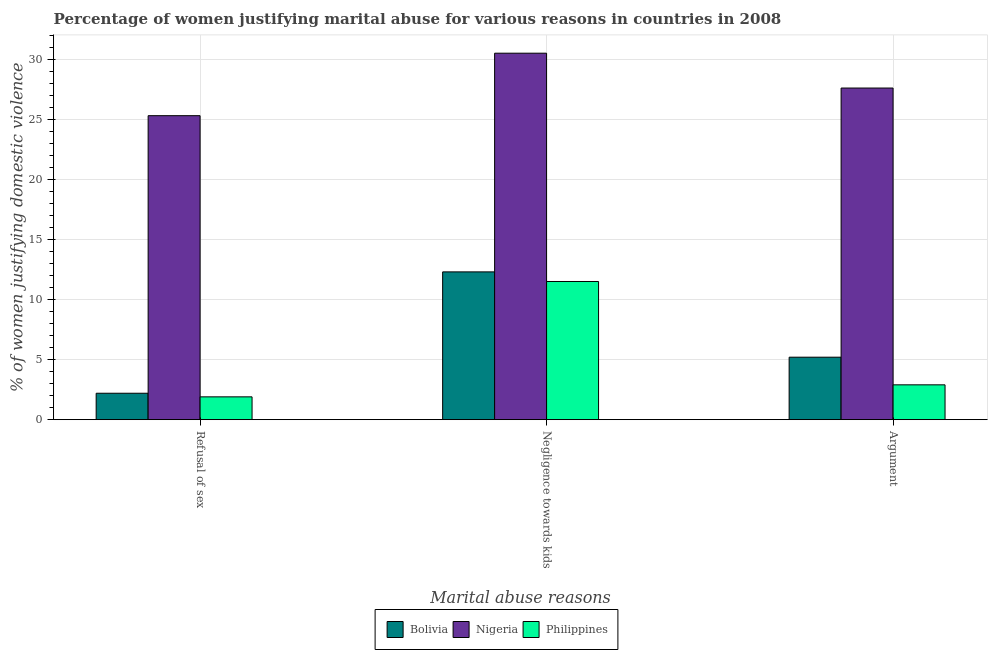How many groups of bars are there?
Offer a very short reply. 3. What is the label of the 2nd group of bars from the left?
Offer a terse response. Negligence towards kids. What is the percentage of women justifying domestic violence due to arguments in Nigeria?
Give a very brief answer. 27.6. Across all countries, what is the maximum percentage of women justifying domestic violence due to arguments?
Provide a succinct answer. 27.6. In which country was the percentage of women justifying domestic violence due to refusal of sex maximum?
Provide a succinct answer. Nigeria. In which country was the percentage of women justifying domestic violence due to negligence towards kids minimum?
Your response must be concise. Philippines. What is the total percentage of women justifying domestic violence due to refusal of sex in the graph?
Your answer should be compact. 29.4. What is the difference between the percentage of women justifying domestic violence due to arguments in Bolivia and that in Philippines?
Offer a terse response. 2.3. What is the difference between the percentage of women justifying domestic violence due to refusal of sex in Nigeria and the percentage of women justifying domestic violence due to arguments in Philippines?
Offer a very short reply. 22.4. What is the average percentage of women justifying domestic violence due to negligence towards kids per country?
Offer a terse response. 18.1. What is the difference between the percentage of women justifying domestic violence due to refusal of sex and percentage of women justifying domestic violence due to negligence towards kids in Bolivia?
Provide a short and direct response. -10.1. What is the ratio of the percentage of women justifying domestic violence due to arguments in Nigeria to that in Philippines?
Your answer should be very brief. 9.52. What is the difference between the highest and the lowest percentage of women justifying domestic violence due to arguments?
Your response must be concise. 24.7. Is the sum of the percentage of women justifying domestic violence due to arguments in Nigeria and Philippines greater than the maximum percentage of women justifying domestic violence due to negligence towards kids across all countries?
Give a very brief answer. No. What does the 2nd bar from the right in Argument represents?
Your answer should be very brief. Nigeria. Is it the case that in every country, the sum of the percentage of women justifying domestic violence due to refusal of sex and percentage of women justifying domestic violence due to negligence towards kids is greater than the percentage of women justifying domestic violence due to arguments?
Your answer should be very brief. Yes. Are all the bars in the graph horizontal?
Keep it short and to the point. No. What is the difference between two consecutive major ticks on the Y-axis?
Your response must be concise. 5. Does the graph contain any zero values?
Offer a very short reply. No. How many legend labels are there?
Ensure brevity in your answer.  3. What is the title of the graph?
Provide a succinct answer. Percentage of women justifying marital abuse for various reasons in countries in 2008. Does "Tanzania" appear as one of the legend labels in the graph?
Offer a very short reply. No. What is the label or title of the X-axis?
Your answer should be compact. Marital abuse reasons. What is the label or title of the Y-axis?
Offer a very short reply. % of women justifying domestic violence. What is the % of women justifying domestic violence in Bolivia in Refusal of sex?
Provide a short and direct response. 2.2. What is the % of women justifying domestic violence of Nigeria in Refusal of sex?
Make the answer very short. 25.3. What is the % of women justifying domestic violence in Nigeria in Negligence towards kids?
Your answer should be very brief. 30.5. What is the % of women justifying domestic violence of Philippines in Negligence towards kids?
Keep it short and to the point. 11.5. What is the % of women justifying domestic violence in Nigeria in Argument?
Your response must be concise. 27.6. What is the % of women justifying domestic violence in Philippines in Argument?
Offer a terse response. 2.9. Across all Marital abuse reasons, what is the maximum % of women justifying domestic violence of Nigeria?
Provide a succinct answer. 30.5. Across all Marital abuse reasons, what is the maximum % of women justifying domestic violence in Philippines?
Make the answer very short. 11.5. Across all Marital abuse reasons, what is the minimum % of women justifying domestic violence of Bolivia?
Ensure brevity in your answer.  2.2. Across all Marital abuse reasons, what is the minimum % of women justifying domestic violence in Nigeria?
Give a very brief answer. 25.3. Across all Marital abuse reasons, what is the minimum % of women justifying domestic violence of Philippines?
Give a very brief answer. 1.9. What is the total % of women justifying domestic violence of Bolivia in the graph?
Ensure brevity in your answer.  19.7. What is the total % of women justifying domestic violence in Nigeria in the graph?
Give a very brief answer. 83.4. What is the difference between the % of women justifying domestic violence in Bolivia in Refusal of sex and that in Negligence towards kids?
Keep it short and to the point. -10.1. What is the difference between the % of women justifying domestic violence in Nigeria in Refusal of sex and that in Negligence towards kids?
Offer a terse response. -5.2. What is the difference between the % of women justifying domestic violence of Philippines in Refusal of sex and that in Negligence towards kids?
Your answer should be compact. -9.6. What is the difference between the % of women justifying domestic violence of Nigeria in Refusal of sex and that in Argument?
Offer a very short reply. -2.3. What is the difference between the % of women justifying domestic violence in Nigeria in Negligence towards kids and that in Argument?
Your response must be concise. 2.9. What is the difference between the % of women justifying domestic violence of Philippines in Negligence towards kids and that in Argument?
Provide a succinct answer. 8.6. What is the difference between the % of women justifying domestic violence in Bolivia in Refusal of sex and the % of women justifying domestic violence in Nigeria in Negligence towards kids?
Keep it short and to the point. -28.3. What is the difference between the % of women justifying domestic violence in Nigeria in Refusal of sex and the % of women justifying domestic violence in Philippines in Negligence towards kids?
Provide a succinct answer. 13.8. What is the difference between the % of women justifying domestic violence in Bolivia in Refusal of sex and the % of women justifying domestic violence in Nigeria in Argument?
Ensure brevity in your answer.  -25.4. What is the difference between the % of women justifying domestic violence in Nigeria in Refusal of sex and the % of women justifying domestic violence in Philippines in Argument?
Give a very brief answer. 22.4. What is the difference between the % of women justifying domestic violence of Bolivia in Negligence towards kids and the % of women justifying domestic violence of Nigeria in Argument?
Offer a very short reply. -15.3. What is the difference between the % of women justifying domestic violence of Bolivia in Negligence towards kids and the % of women justifying domestic violence of Philippines in Argument?
Ensure brevity in your answer.  9.4. What is the difference between the % of women justifying domestic violence of Nigeria in Negligence towards kids and the % of women justifying domestic violence of Philippines in Argument?
Offer a very short reply. 27.6. What is the average % of women justifying domestic violence in Bolivia per Marital abuse reasons?
Offer a very short reply. 6.57. What is the average % of women justifying domestic violence of Nigeria per Marital abuse reasons?
Ensure brevity in your answer.  27.8. What is the average % of women justifying domestic violence of Philippines per Marital abuse reasons?
Give a very brief answer. 5.43. What is the difference between the % of women justifying domestic violence of Bolivia and % of women justifying domestic violence of Nigeria in Refusal of sex?
Give a very brief answer. -23.1. What is the difference between the % of women justifying domestic violence of Nigeria and % of women justifying domestic violence of Philippines in Refusal of sex?
Offer a terse response. 23.4. What is the difference between the % of women justifying domestic violence of Bolivia and % of women justifying domestic violence of Nigeria in Negligence towards kids?
Make the answer very short. -18.2. What is the difference between the % of women justifying domestic violence of Bolivia and % of women justifying domestic violence of Nigeria in Argument?
Your answer should be very brief. -22.4. What is the difference between the % of women justifying domestic violence of Bolivia and % of women justifying domestic violence of Philippines in Argument?
Provide a succinct answer. 2.3. What is the difference between the % of women justifying domestic violence of Nigeria and % of women justifying domestic violence of Philippines in Argument?
Offer a very short reply. 24.7. What is the ratio of the % of women justifying domestic violence of Bolivia in Refusal of sex to that in Negligence towards kids?
Give a very brief answer. 0.18. What is the ratio of the % of women justifying domestic violence of Nigeria in Refusal of sex to that in Negligence towards kids?
Your answer should be compact. 0.83. What is the ratio of the % of women justifying domestic violence of Philippines in Refusal of sex to that in Negligence towards kids?
Your answer should be compact. 0.17. What is the ratio of the % of women justifying domestic violence of Bolivia in Refusal of sex to that in Argument?
Keep it short and to the point. 0.42. What is the ratio of the % of women justifying domestic violence of Nigeria in Refusal of sex to that in Argument?
Your answer should be compact. 0.92. What is the ratio of the % of women justifying domestic violence of Philippines in Refusal of sex to that in Argument?
Keep it short and to the point. 0.66. What is the ratio of the % of women justifying domestic violence in Bolivia in Negligence towards kids to that in Argument?
Provide a succinct answer. 2.37. What is the ratio of the % of women justifying domestic violence of Nigeria in Negligence towards kids to that in Argument?
Give a very brief answer. 1.11. What is the ratio of the % of women justifying domestic violence of Philippines in Negligence towards kids to that in Argument?
Provide a succinct answer. 3.97. What is the difference between the highest and the second highest % of women justifying domestic violence of Philippines?
Offer a terse response. 8.6. What is the difference between the highest and the lowest % of women justifying domestic violence in Bolivia?
Provide a short and direct response. 10.1. What is the difference between the highest and the lowest % of women justifying domestic violence of Philippines?
Your answer should be very brief. 9.6. 